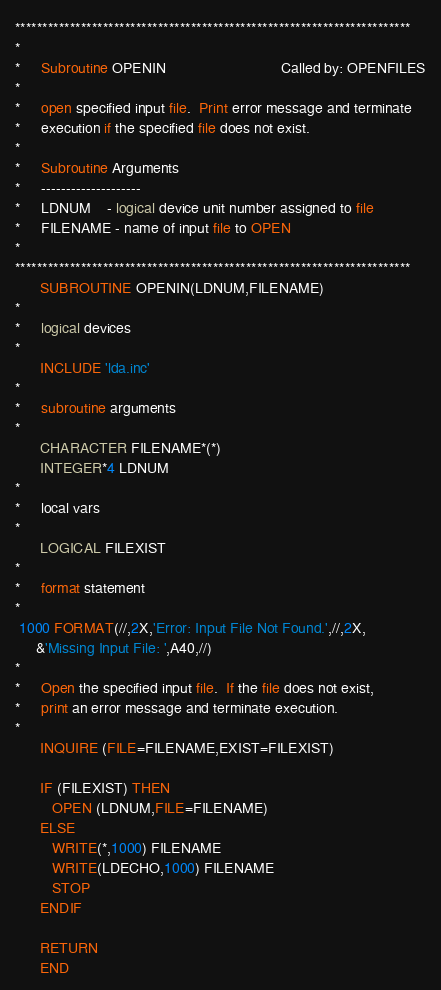<code> <loc_0><loc_0><loc_500><loc_500><_FORTRAN_>************************************************************************
*
*     Subroutine OPENIN                            Called by: OPENFILES
*
*     open specified input file.  Print error message and terminate
*     execution if the specified file does not exist.
*
*     Subroutine Arguments
*     --------------------
*     LDNUM    - logical device unit number assigned to file
*     FILENAME - name of input file to OPEN
*
************************************************************************
      SUBROUTINE OPENIN(LDNUM,FILENAME)
*
*     logical devices
*
      INCLUDE 'lda.inc'
*
*     subroutine arguments
*
      CHARACTER FILENAME*(*)
      INTEGER*4 LDNUM
*
*     local vars
*
      LOGICAL FILEXIST
*
*     format statement
*
 1000 FORMAT(//,2X,'Error: Input File Not Found.',//,2X,
     &'Missing Input File: ',A40,//)
*
*     Open the specified input file.  If the file does not exist,
*     print an error message and terminate execution.
*
      INQUIRE (FILE=FILENAME,EXIST=FILEXIST)

      IF (FILEXIST) THEN
         OPEN (LDNUM,FILE=FILENAME)
      ELSE
         WRITE(*,1000) FILENAME
         WRITE(LDECHO,1000) FILENAME
         STOP 
      ENDIF

      RETURN
      END
</code> 